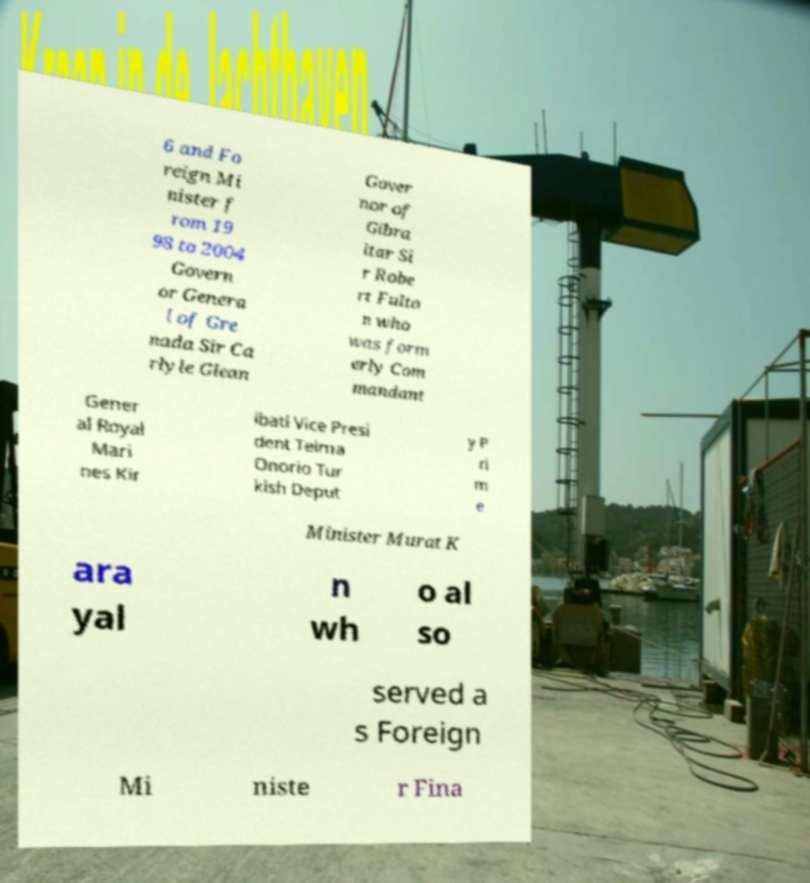Could you assist in decoding the text presented in this image and type it out clearly? 6 and Fo reign Mi nister f rom 19 98 to 2004 Govern or Genera l of Gre nada Sir Ca rlyle Glean Gover nor of Gibra ltar Si r Robe rt Fulto n who was form erly Com mandant Gener al Royal Mari nes Kir ibati Vice Presi dent Teima Onorio Tur kish Deput y P ri m e Minister Murat K ara yal n wh o al so served a s Foreign Mi niste r Fina 